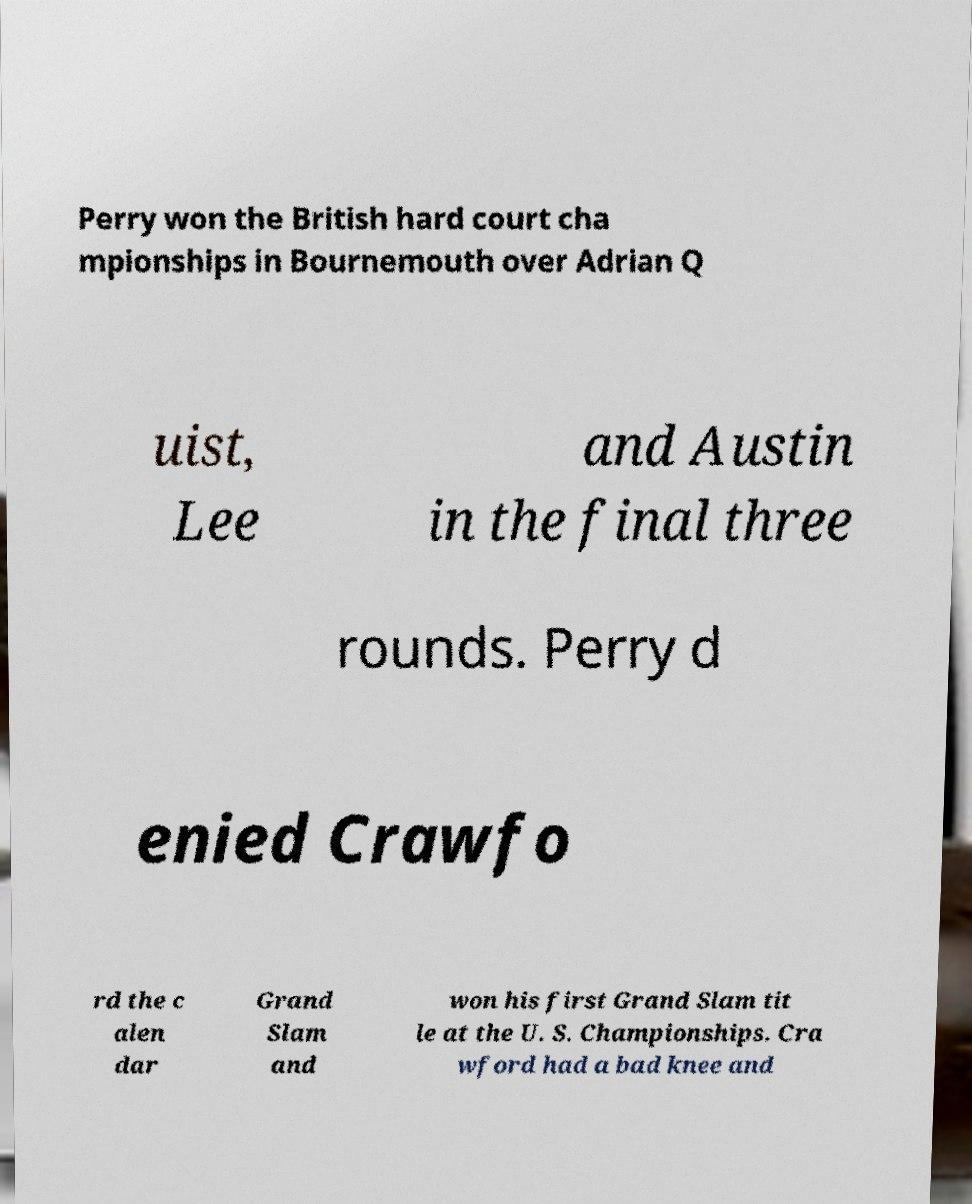Can you accurately transcribe the text from the provided image for me? Perry won the British hard court cha mpionships in Bournemouth over Adrian Q uist, Lee and Austin in the final three rounds. Perry d enied Crawfo rd the c alen dar Grand Slam and won his first Grand Slam tit le at the U. S. Championships. Cra wford had a bad knee and 